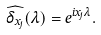<formula> <loc_0><loc_0><loc_500><loc_500>\widehat { \delta _ { x _ { j } } } ( \lambda ) = e ^ { i x _ { j } \lambda } .</formula> 